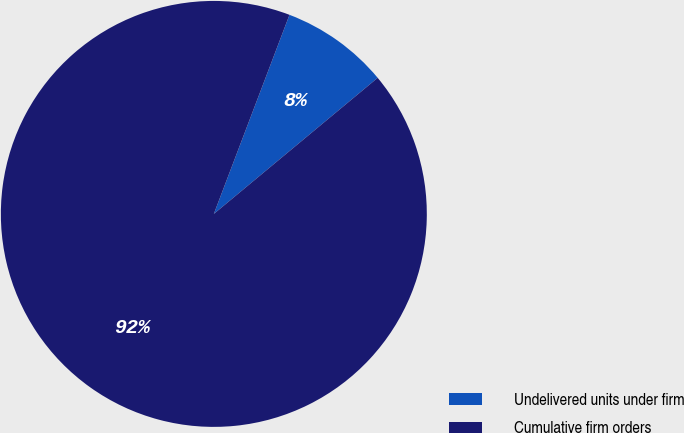<chart> <loc_0><loc_0><loc_500><loc_500><pie_chart><fcel>Undelivered units under firm<fcel>Cumulative firm orders<nl><fcel>8.19%<fcel>91.81%<nl></chart> 